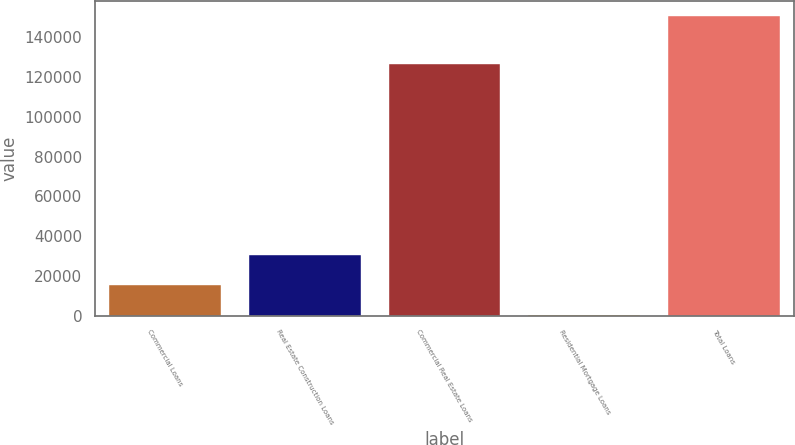Convert chart. <chart><loc_0><loc_0><loc_500><loc_500><bar_chart><fcel>Commercial Loans<fcel>Real Estate Construction Loans<fcel>Commercial Real Estate Loans<fcel>Residential Mortgage Loans<fcel>Total Loans<nl><fcel>15181.5<fcel>30263<fcel>126607<fcel>100<fcel>150915<nl></chart> 